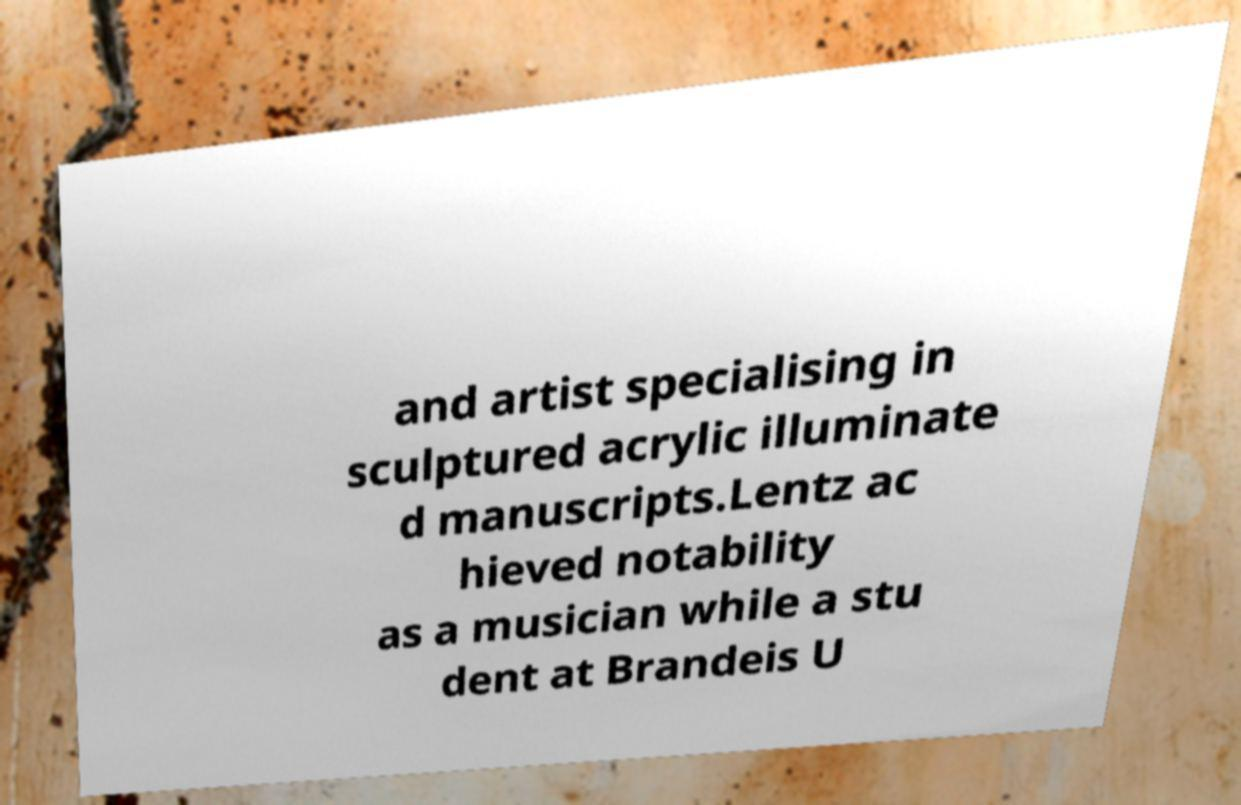Could you extract and type out the text from this image? and artist specialising in sculptured acrylic illuminate d manuscripts.Lentz ac hieved notability as a musician while a stu dent at Brandeis U 